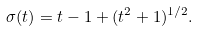Convert formula to latex. <formula><loc_0><loc_0><loc_500><loc_500>\sigma ( t ) = t - 1 + ( t ^ { 2 } + 1 ) ^ { 1 / 2 } .</formula> 